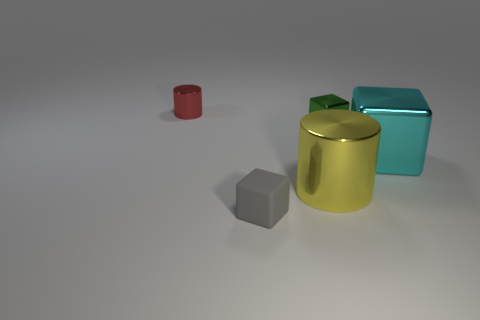Is the size of the yellow metal thing the same as the metallic thing on the left side of the matte object?
Your answer should be compact. No. Are there the same number of large yellow metallic things and tiny matte cylinders?
Make the answer very short. No. There is a metal cylinder behind the metallic cylinder on the right side of the red thing; how many small cubes are behind it?
Your answer should be compact. 0. There is a gray rubber cube; how many large cyan blocks are in front of it?
Make the answer very short. 0. What is the color of the cylinder in front of the metal cylinder left of the small gray cube?
Your answer should be compact. Yellow. How many other objects are the same material as the large yellow cylinder?
Provide a succinct answer. 3. Are there an equal number of large yellow things that are right of the yellow object and big purple objects?
Your answer should be compact. Yes. What is the material of the cylinder in front of the metal object that is on the left side of the big metal object that is on the left side of the big block?
Provide a short and direct response. Metal. There is a metal cylinder that is to the left of the rubber thing; what color is it?
Provide a short and direct response. Red. Is there anything else that is the same shape as the cyan shiny object?
Your answer should be compact. Yes. 